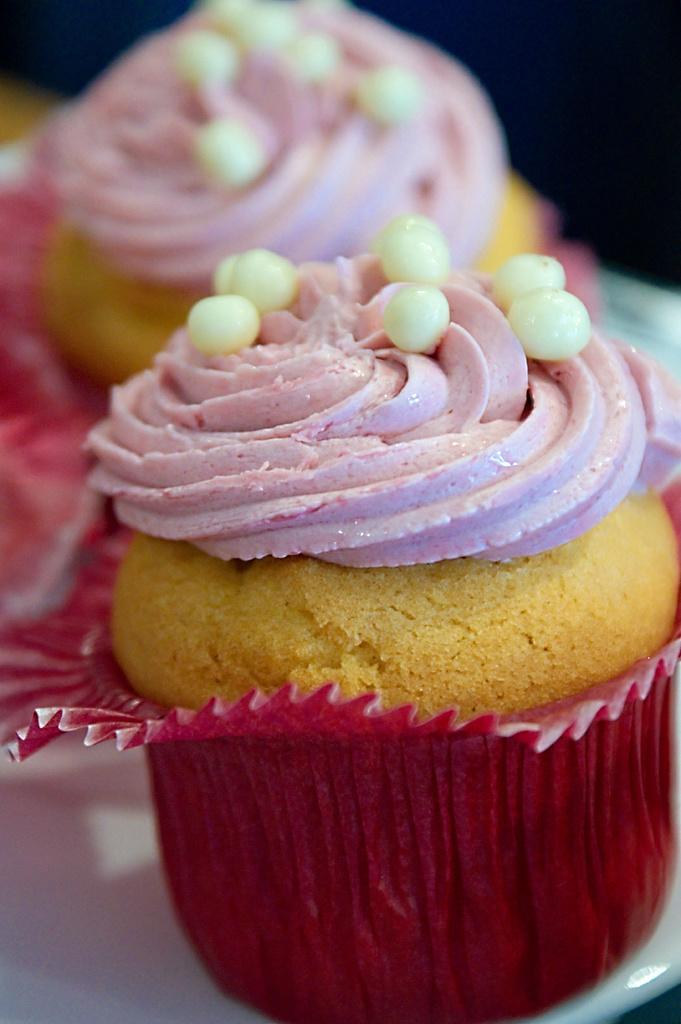Describe this image in one or two sentences. As we can see in the image there is a white color plate. On plate there are cupcakes. 